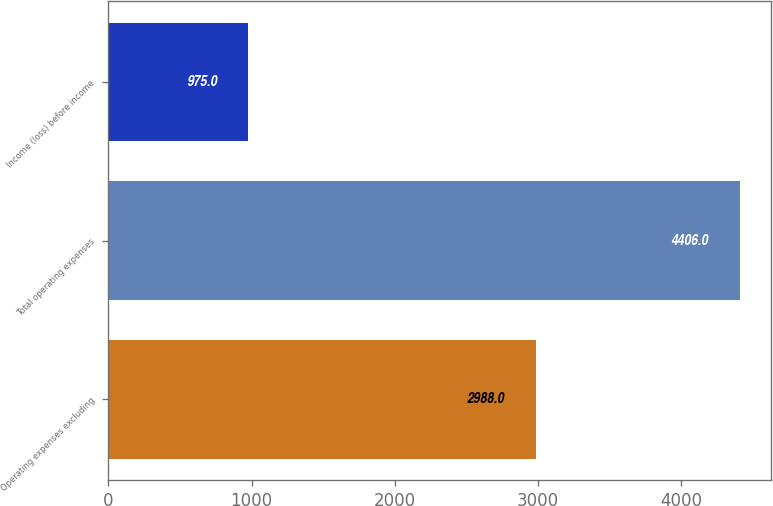Convert chart to OTSL. <chart><loc_0><loc_0><loc_500><loc_500><bar_chart><fcel>Operating expenses excluding<fcel>Total operating expenses<fcel>Income (loss) before income<nl><fcel>2988<fcel>4406<fcel>975<nl></chart> 